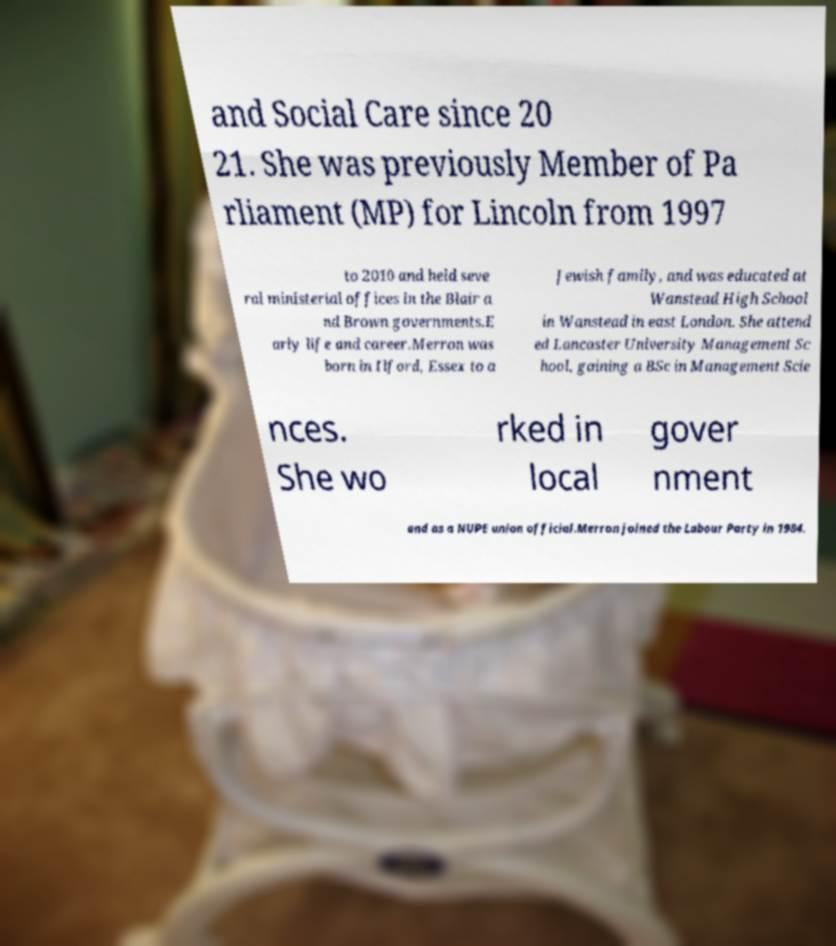For documentation purposes, I need the text within this image transcribed. Could you provide that? and Social Care since 20 21. She was previously Member of Pa rliament (MP) for Lincoln from 1997 to 2010 and held seve ral ministerial offices in the Blair a nd Brown governments.E arly life and career.Merron was born in Ilford, Essex to a Jewish family, and was educated at Wanstead High School in Wanstead in east London. She attend ed Lancaster University Management Sc hool, gaining a BSc in Management Scie nces. She wo rked in local gover nment and as a NUPE union official.Merron joined the Labour Party in 1984. 